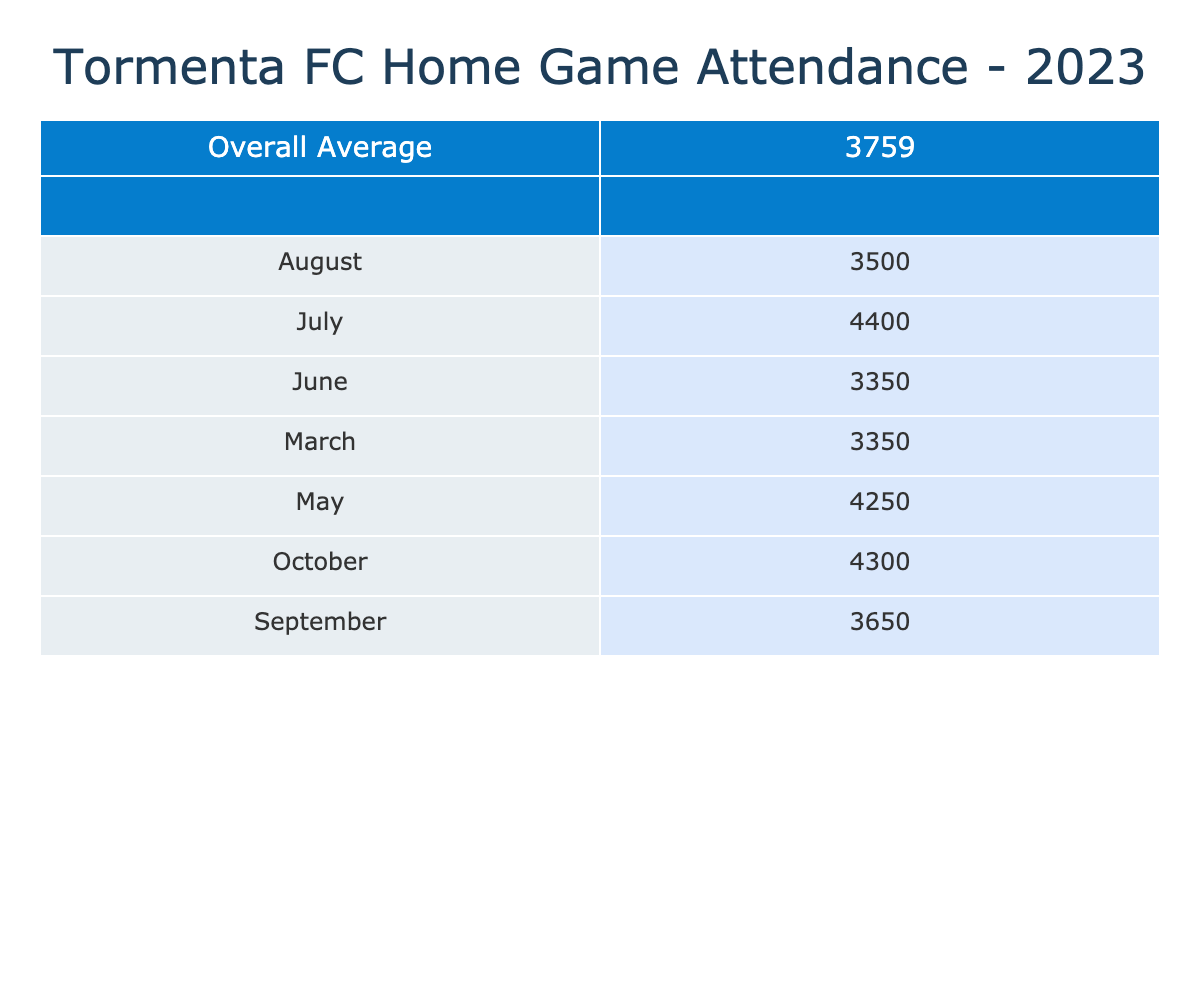What was the highest attendance for a home game in 2023? The highest attendance recorded in the table is 4600, which occurred in July for the game against FC Tucson on July 22.
Answer: 4600 What is the average attendance for home games in June? The attendance figures for June are 3100 and 3600. To find the average, add these two numbers (3100 + 3600 = 6700), then divide by 2 (6700 / 2 = 3350).
Answer: 3350 Did Tormenta FC have an average attendance above 4000 in any month? To find this, we check the average attendance for each month: March (3350), April (3275), May (4250), June (3350), July (4400), August (3500), September (3650), October (4300). April and August are below 4000, so they didn’t exceed it. Yes, in May, July, and October, the average is above 4000.
Answer: Yes What is the overall average attendance for all home games in 2023? To calculate this, we sum up all the attendance figures (3200 + 3500 + 3800 + 2750 + 4000 + 4500 + 3100 + 3600 + 4200 + 4600 + 3300 + 3700 + 3400 + 3900 + 4100 + 4500) and divide by the total number of games (16). The total attendance equals 64600, so the overall average is 64600 / 16 = 4037.5, which rounds to 4038.
Answer: 4038 Which opponent had the lowest attendance recorded in a home game? In the table, the lowest recorded attendance was 2750 for the home game against South Georgia Tormenta II on April 29.
Answer: 2750 